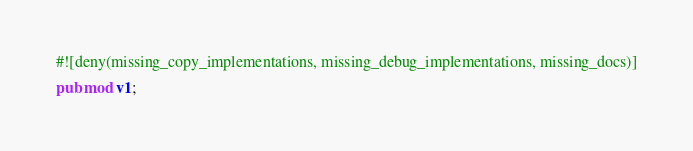<code> <loc_0><loc_0><loc_500><loc_500><_Rust_>#![deny(missing_copy_implementations, missing_debug_implementations, missing_docs)]

pub mod v1;
</code> 